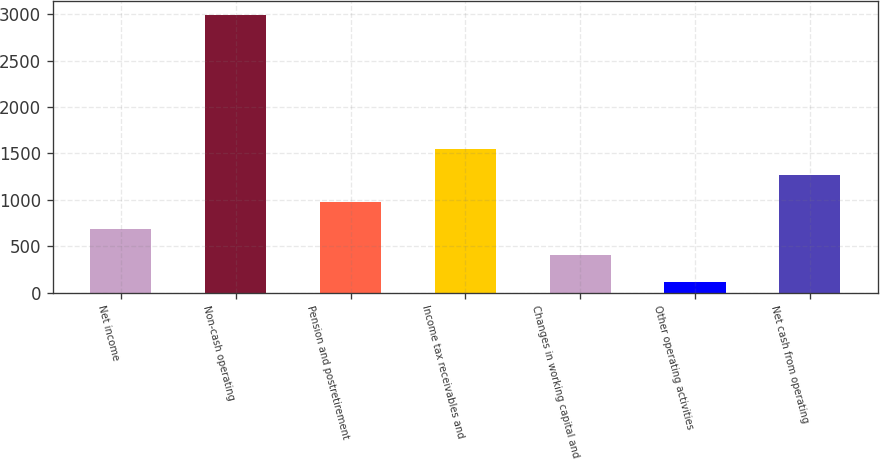<chart> <loc_0><loc_0><loc_500><loc_500><bar_chart><fcel>Net income<fcel>Non-cash operating<fcel>Pension and postretirement<fcel>Income tax receivables and<fcel>Changes in working capital and<fcel>Other operating activities<fcel>Net cash from operating<nl><fcel>689<fcel>2989<fcel>976.5<fcel>1551.5<fcel>401.5<fcel>114<fcel>1264<nl></chart> 